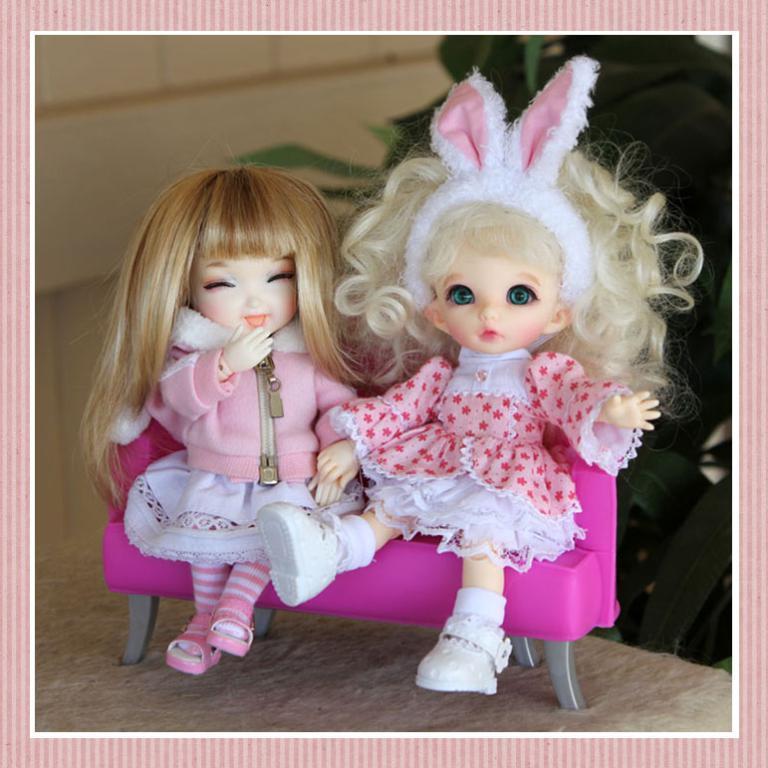Please provide a concise description of this image. In this image we can see a photograph on a platform and in the photo we can see two dolls are sitting on a sofa on the floor and in the background we can see the wall and plants. 